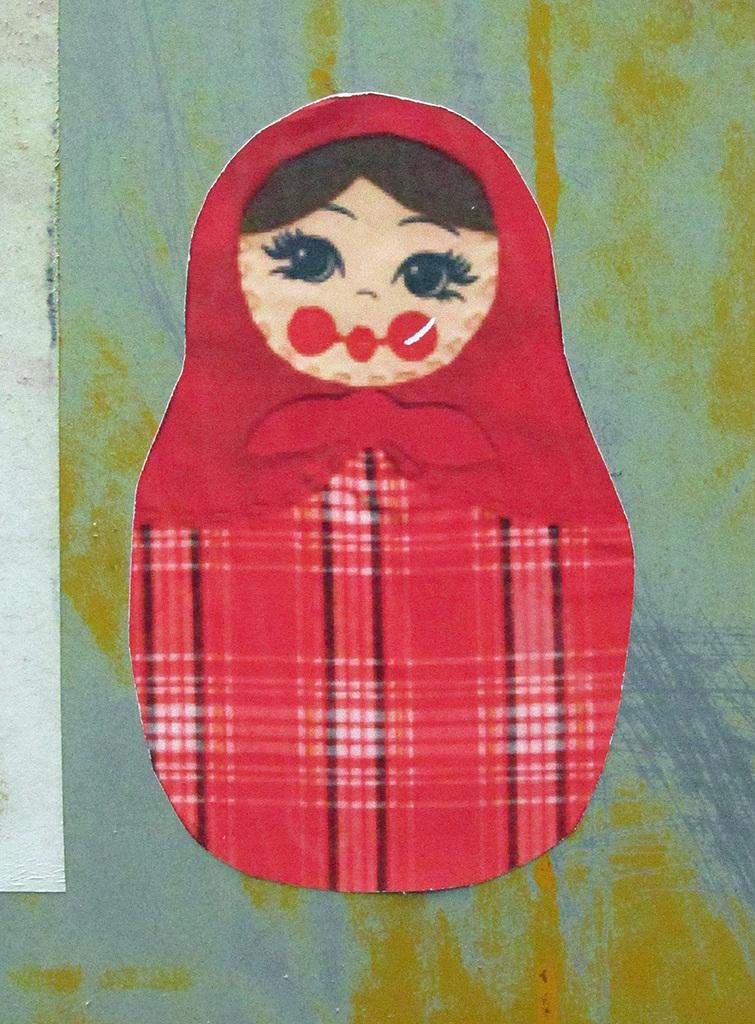What is the main subject of the painting in the image? The main subject of the painting in the image is a kid. What is the kid in the painting wearing? The kid in the painting is wearing a red dress. What type of jeans is the kid wearing in the painting? The painting does not depict the kid wearing jeans; the kid is wearing a red dress. 